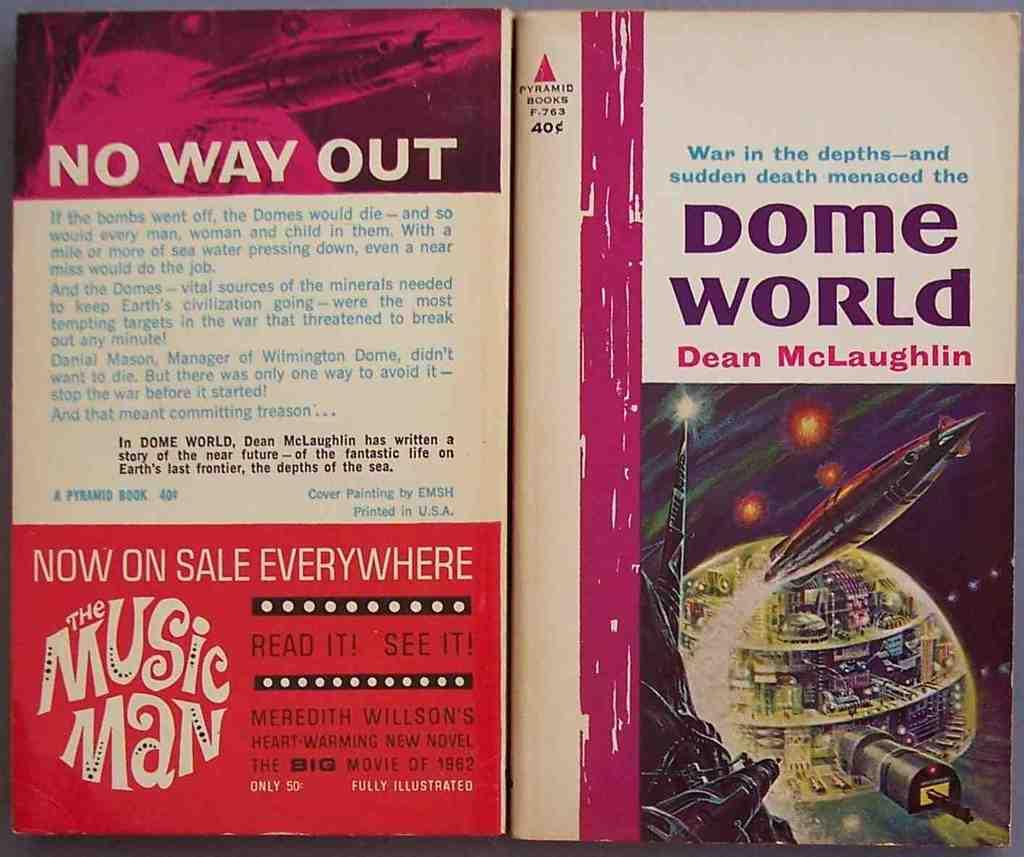<image>
Give a short and clear explanation of the subsequent image. The front and back cover of a book titled "Dome World" by Dean McLaughlin tells about a book where people live in domes. 